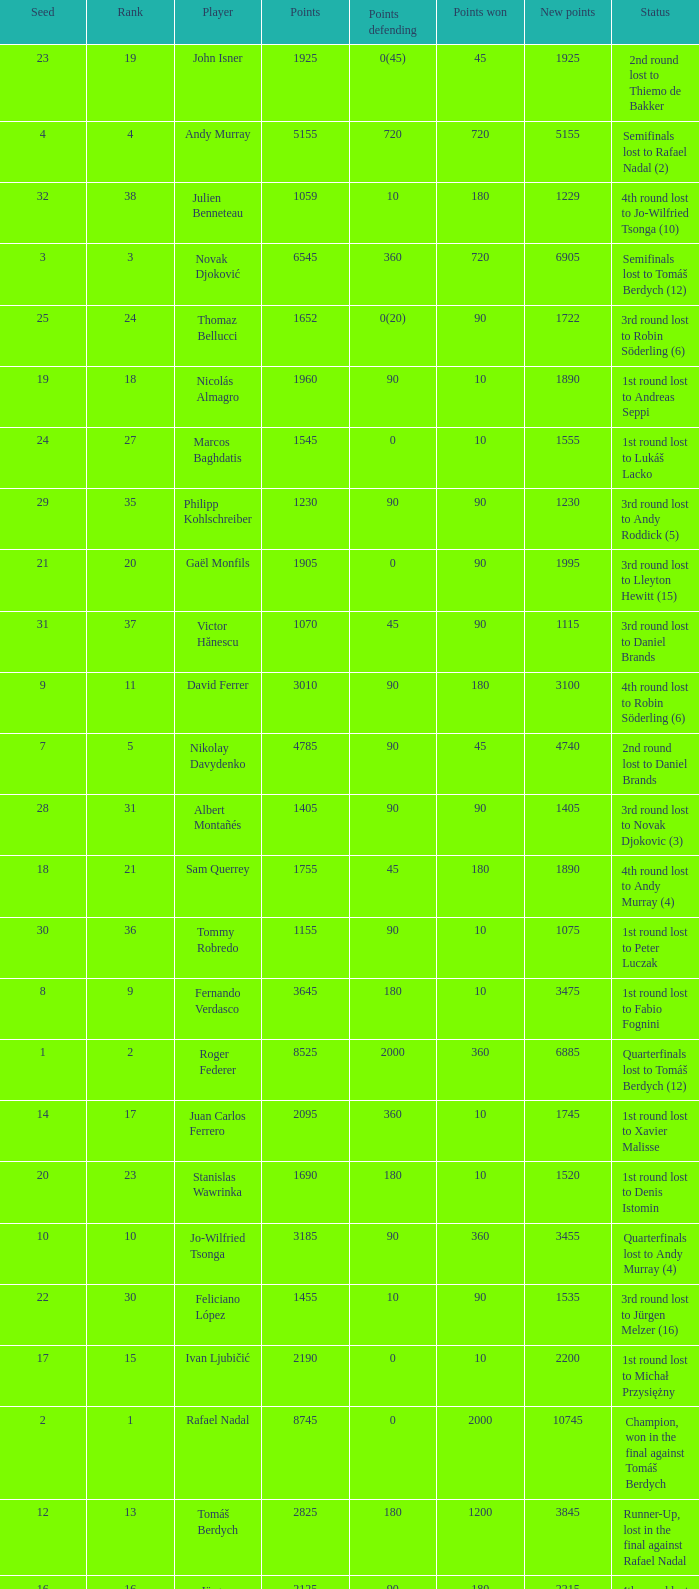Name the least new points for points defending is 1200 3490.0. 